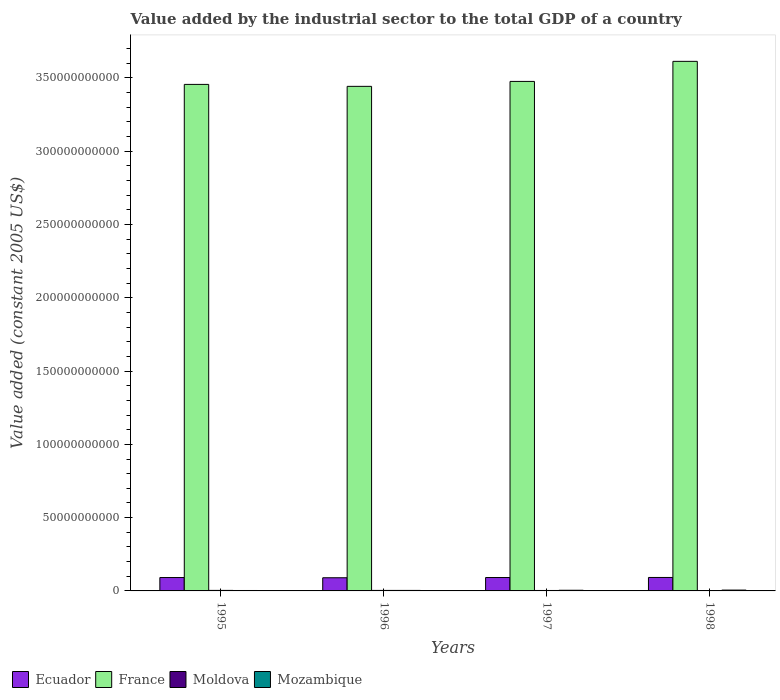How many groups of bars are there?
Make the answer very short. 4. Are the number of bars per tick equal to the number of legend labels?
Your answer should be compact. Yes. Are the number of bars on each tick of the X-axis equal?
Your answer should be compact. Yes. How many bars are there on the 3rd tick from the left?
Your response must be concise. 4. How many bars are there on the 3rd tick from the right?
Provide a short and direct response. 4. In how many cases, is the number of bars for a given year not equal to the number of legend labels?
Your response must be concise. 0. What is the value added by the industrial sector in France in 1998?
Keep it short and to the point. 3.61e+11. Across all years, what is the maximum value added by the industrial sector in France?
Your answer should be very brief. 3.61e+11. Across all years, what is the minimum value added by the industrial sector in Ecuador?
Your response must be concise. 8.99e+09. What is the total value added by the industrial sector in Moldova in the graph?
Give a very brief answer. 1.26e+09. What is the difference between the value added by the industrial sector in Mozambique in 1995 and that in 1996?
Provide a succinct answer. -5.12e+07. What is the difference between the value added by the industrial sector in Ecuador in 1998 and the value added by the industrial sector in France in 1996?
Your answer should be compact. -3.35e+11. What is the average value added by the industrial sector in Mozambique per year?
Offer a very short reply. 4.16e+08. In the year 1996, what is the difference between the value added by the industrial sector in Moldova and value added by the industrial sector in Ecuador?
Provide a short and direct response. -8.64e+09. What is the ratio of the value added by the industrial sector in Mozambique in 1996 to that in 1998?
Offer a terse response. 0.61. Is the value added by the industrial sector in Moldova in 1996 less than that in 1997?
Keep it short and to the point. No. Is the difference between the value added by the industrial sector in Moldova in 1996 and 1998 greater than the difference between the value added by the industrial sector in Ecuador in 1996 and 1998?
Your answer should be compact. Yes. What is the difference between the highest and the second highest value added by the industrial sector in Ecuador?
Your response must be concise. 4.20e+07. What is the difference between the highest and the lowest value added by the industrial sector in France?
Ensure brevity in your answer.  1.71e+1. In how many years, is the value added by the industrial sector in Mozambique greater than the average value added by the industrial sector in Mozambique taken over all years?
Your response must be concise. 2. Is it the case that in every year, the sum of the value added by the industrial sector in Moldova and value added by the industrial sector in France is greater than the sum of value added by the industrial sector in Mozambique and value added by the industrial sector in Ecuador?
Your answer should be compact. Yes. What does the 2nd bar from the left in 1995 represents?
Provide a short and direct response. France. What does the 4th bar from the right in 1995 represents?
Give a very brief answer. Ecuador. Is it the case that in every year, the sum of the value added by the industrial sector in Mozambique and value added by the industrial sector in Moldova is greater than the value added by the industrial sector in Ecuador?
Make the answer very short. No. How many bars are there?
Provide a short and direct response. 16. Are all the bars in the graph horizontal?
Ensure brevity in your answer.  No. What is the difference between two consecutive major ticks on the Y-axis?
Keep it short and to the point. 5.00e+1. Are the values on the major ticks of Y-axis written in scientific E-notation?
Make the answer very short. No. Does the graph contain grids?
Offer a very short reply. No. Where does the legend appear in the graph?
Give a very brief answer. Bottom left. How many legend labels are there?
Provide a succinct answer. 4. What is the title of the graph?
Provide a succinct answer. Value added by the industrial sector to the total GDP of a country. Does "Finland" appear as one of the legend labels in the graph?
Offer a terse response. No. What is the label or title of the Y-axis?
Your answer should be very brief. Value added (constant 2005 US$). What is the Value added (constant 2005 US$) in Ecuador in 1995?
Your response must be concise. 9.13e+09. What is the Value added (constant 2005 US$) in France in 1995?
Provide a succinct answer. 3.46e+11. What is the Value added (constant 2005 US$) of Moldova in 1995?
Your answer should be very brief. 3.52e+08. What is the Value added (constant 2005 US$) of Mozambique in 1995?
Keep it short and to the point. 2.97e+08. What is the Value added (constant 2005 US$) in Ecuador in 1996?
Provide a succinct answer. 8.99e+09. What is the Value added (constant 2005 US$) of France in 1996?
Your answer should be very brief. 3.44e+11. What is the Value added (constant 2005 US$) in Moldova in 1996?
Offer a terse response. 3.45e+08. What is the Value added (constant 2005 US$) in Mozambique in 1996?
Ensure brevity in your answer.  3.48e+08. What is the Value added (constant 2005 US$) in Ecuador in 1997?
Offer a terse response. 9.14e+09. What is the Value added (constant 2005 US$) of France in 1997?
Provide a succinct answer. 3.48e+11. What is the Value added (constant 2005 US$) in Moldova in 1997?
Offer a very short reply. 3.05e+08. What is the Value added (constant 2005 US$) in Mozambique in 1997?
Make the answer very short. 4.52e+08. What is the Value added (constant 2005 US$) of Ecuador in 1998?
Give a very brief answer. 9.19e+09. What is the Value added (constant 2005 US$) of France in 1998?
Provide a short and direct response. 3.61e+11. What is the Value added (constant 2005 US$) in Moldova in 1998?
Offer a terse response. 2.59e+08. What is the Value added (constant 2005 US$) in Mozambique in 1998?
Your answer should be compact. 5.69e+08. Across all years, what is the maximum Value added (constant 2005 US$) in Ecuador?
Your answer should be compact. 9.19e+09. Across all years, what is the maximum Value added (constant 2005 US$) of France?
Give a very brief answer. 3.61e+11. Across all years, what is the maximum Value added (constant 2005 US$) in Moldova?
Offer a very short reply. 3.52e+08. Across all years, what is the maximum Value added (constant 2005 US$) in Mozambique?
Provide a succinct answer. 5.69e+08. Across all years, what is the minimum Value added (constant 2005 US$) in Ecuador?
Your answer should be compact. 8.99e+09. Across all years, what is the minimum Value added (constant 2005 US$) of France?
Give a very brief answer. 3.44e+11. Across all years, what is the minimum Value added (constant 2005 US$) of Moldova?
Give a very brief answer. 2.59e+08. Across all years, what is the minimum Value added (constant 2005 US$) in Mozambique?
Your answer should be compact. 2.97e+08. What is the total Value added (constant 2005 US$) of Ecuador in the graph?
Offer a very short reply. 3.65e+1. What is the total Value added (constant 2005 US$) of France in the graph?
Ensure brevity in your answer.  1.40e+12. What is the total Value added (constant 2005 US$) in Moldova in the graph?
Your answer should be very brief. 1.26e+09. What is the total Value added (constant 2005 US$) in Mozambique in the graph?
Ensure brevity in your answer.  1.67e+09. What is the difference between the Value added (constant 2005 US$) of Ecuador in 1995 and that in 1996?
Ensure brevity in your answer.  1.48e+08. What is the difference between the Value added (constant 2005 US$) of France in 1995 and that in 1996?
Your answer should be compact. 1.33e+09. What is the difference between the Value added (constant 2005 US$) in Moldova in 1995 and that in 1996?
Ensure brevity in your answer.  7.55e+06. What is the difference between the Value added (constant 2005 US$) in Mozambique in 1995 and that in 1996?
Offer a very short reply. -5.12e+07. What is the difference between the Value added (constant 2005 US$) in Ecuador in 1995 and that in 1997?
Provide a short and direct response. -9.61e+06. What is the difference between the Value added (constant 2005 US$) in France in 1995 and that in 1997?
Offer a terse response. -2.03e+09. What is the difference between the Value added (constant 2005 US$) in Moldova in 1995 and that in 1997?
Keep it short and to the point. 4.72e+07. What is the difference between the Value added (constant 2005 US$) in Mozambique in 1995 and that in 1997?
Provide a short and direct response. -1.55e+08. What is the difference between the Value added (constant 2005 US$) in Ecuador in 1995 and that in 1998?
Ensure brevity in your answer.  -5.16e+07. What is the difference between the Value added (constant 2005 US$) of France in 1995 and that in 1998?
Make the answer very short. -1.57e+1. What is the difference between the Value added (constant 2005 US$) of Moldova in 1995 and that in 1998?
Give a very brief answer. 9.35e+07. What is the difference between the Value added (constant 2005 US$) of Mozambique in 1995 and that in 1998?
Your response must be concise. -2.72e+08. What is the difference between the Value added (constant 2005 US$) in Ecuador in 1996 and that in 1997?
Make the answer very short. -1.57e+08. What is the difference between the Value added (constant 2005 US$) in France in 1996 and that in 1997?
Give a very brief answer. -3.36e+09. What is the difference between the Value added (constant 2005 US$) in Moldova in 1996 and that in 1997?
Provide a succinct answer. 3.97e+07. What is the difference between the Value added (constant 2005 US$) of Mozambique in 1996 and that in 1997?
Offer a very short reply. -1.04e+08. What is the difference between the Value added (constant 2005 US$) of Ecuador in 1996 and that in 1998?
Provide a short and direct response. -1.99e+08. What is the difference between the Value added (constant 2005 US$) in France in 1996 and that in 1998?
Ensure brevity in your answer.  -1.71e+1. What is the difference between the Value added (constant 2005 US$) of Moldova in 1996 and that in 1998?
Provide a succinct answer. 8.60e+07. What is the difference between the Value added (constant 2005 US$) of Mozambique in 1996 and that in 1998?
Ensure brevity in your answer.  -2.21e+08. What is the difference between the Value added (constant 2005 US$) in Ecuador in 1997 and that in 1998?
Provide a succinct answer. -4.20e+07. What is the difference between the Value added (constant 2005 US$) in France in 1997 and that in 1998?
Provide a succinct answer. -1.37e+1. What is the difference between the Value added (constant 2005 US$) of Moldova in 1997 and that in 1998?
Your answer should be very brief. 4.63e+07. What is the difference between the Value added (constant 2005 US$) in Mozambique in 1997 and that in 1998?
Ensure brevity in your answer.  -1.17e+08. What is the difference between the Value added (constant 2005 US$) of Ecuador in 1995 and the Value added (constant 2005 US$) of France in 1996?
Your answer should be compact. -3.35e+11. What is the difference between the Value added (constant 2005 US$) in Ecuador in 1995 and the Value added (constant 2005 US$) in Moldova in 1996?
Offer a terse response. 8.79e+09. What is the difference between the Value added (constant 2005 US$) in Ecuador in 1995 and the Value added (constant 2005 US$) in Mozambique in 1996?
Offer a terse response. 8.79e+09. What is the difference between the Value added (constant 2005 US$) of France in 1995 and the Value added (constant 2005 US$) of Moldova in 1996?
Keep it short and to the point. 3.45e+11. What is the difference between the Value added (constant 2005 US$) in France in 1995 and the Value added (constant 2005 US$) in Mozambique in 1996?
Keep it short and to the point. 3.45e+11. What is the difference between the Value added (constant 2005 US$) of Moldova in 1995 and the Value added (constant 2005 US$) of Mozambique in 1996?
Your answer should be compact. 4.58e+06. What is the difference between the Value added (constant 2005 US$) of Ecuador in 1995 and the Value added (constant 2005 US$) of France in 1997?
Your answer should be very brief. -3.39e+11. What is the difference between the Value added (constant 2005 US$) of Ecuador in 1995 and the Value added (constant 2005 US$) of Moldova in 1997?
Give a very brief answer. 8.83e+09. What is the difference between the Value added (constant 2005 US$) in Ecuador in 1995 and the Value added (constant 2005 US$) in Mozambique in 1997?
Your answer should be very brief. 8.68e+09. What is the difference between the Value added (constant 2005 US$) of France in 1995 and the Value added (constant 2005 US$) of Moldova in 1997?
Provide a succinct answer. 3.45e+11. What is the difference between the Value added (constant 2005 US$) in France in 1995 and the Value added (constant 2005 US$) in Mozambique in 1997?
Your response must be concise. 3.45e+11. What is the difference between the Value added (constant 2005 US$) in Moldova in 1995 and the Value added (constant 2005 US$) in Mozambique in 1997?
Provide a short and direct response. -9.92e+07. What is the difference between the Value added (constant 2005 US$) of Ecuador in 1995 and the Value added (constant 2005 US$) of France in 1998?
Make the answer very short. -3.52e+11. What is the difference between the Value added (constant 2005 US$) of Ecuador in 1995 and the Value added (constant 2005 US$) of Moldova in 1998?
Make the answer very short. 8.88e+09. What is the difference between the Value added (constant 2005 US$) of Ecuador in 1995 and the Value added (constant 2005 US$) of Mozambique in 1998?
Provide a short and direct response. 8.57e+09. What is the difference between the Value added (constant 2005 US$) in France in 1995 and the Value added (constant 2005 US$) in Moldova in 1998?
Offer a very short reply. 3.45e+11. What is the difference between the Value added (constant 2005 US$) in France in 1995 and the Value added (constant 2005 US$) in Mozambique in 1998?
Your answer should be very brief. 3.45e+11. What is the difference between the Value added (constant 2005 US$) of Moldova in 1995 and the Value added (constant 2005 US$) of Mozambique in 1998?
Ensure brevity in your answer.  -2.17e+08. What is the difference between the Value added (constant 2005 US$) of Ecuador in 1996 and the Value added (constant 2005 US$) of France in 1997?
Provide a short and direct response. -3.39e+11. What is the difference between the Value added (constant 2005 US$) of Ecuador in 1996 and the Value added (constant 2005 US$) of Moldova in 1997?
Your answer should be compact. 8.68e+09. What is the difference between the Value added (constant 2005 US$) of Ecuador in 1996 and the Value added (constant 2005 US$) of Mozambique in 1997?
Ensure brevity in your answer.  8.53e+09. What is the difference between the Value added (constant 2005 US$) of France in 1996 and the Value added (constant 2005 US$) of Moldova in 1997?
Your response must be concise. 3.44e+11. What is the difference between the Value added (constant 2005 US$) in France in 1996 and the Value added (constant 2005 US$) in Mozambique in 1997?
Provide a short and direct response. 3.44e+11. What is the difference between the Value added (constant 2005 US$) in Moldova in 1996 and the Value added (constant 2005 US$) in Mozambique in 1997?
Make the answer very short. -1.07e+08. What is the difference between the Value added (constant 2005 US$) in Ecuador in 1996 and the Value added (constant 2005 US$) in France in 1998?
Make the answer very short. -3.52e+11. What is the difference between the Value added (constant 2005 US$) in Ecuador in 1996 and the Value added (constant 2005 US$) in Moldova in 1998?
Provide a succinct answer. 8.73e+09. What is the difference between the Value added (constant 2005 US$) in Ecuador in 1996 and the Value added (constant 2005 US$) in Mozambique in 1998?
Your answer should be very brief. 8.42e+09. What is the difference between the Value added (constant 2005 US$) of France in 1996 and the Value added (constant 2005 US$) of Moldova in 1998?
Your response must be concise. 3.44e+11. What is the difference between the Value added (constant 2005 US$) of France in 1996 and the Value added (constant 2005 US$) of Mozambique in 1998?
Your answer should be compact. 3.44e+11. What is the difference between the Value added (constant 2005 US$) in Moldova in 1996 and the Value added (constant 2005 US$) in Mozambique in 1998?
Your answer should be very brief. -2.24e+08. What is the difference between the Value added (constant 2005 US$) of Ecuador in 1997 and the Value added (constant 2005 US$) of France in 1998?
Your response must be concise. -3.52e+11. What is the difference between the Value added (constant 2005 US$) of Ecuador in 1997 and the Value added (constant 2005 US$) of Moldova in 1998?
Give a very brief answer. 8.89e+09. What is the difference between the Value added (constant 2005 US$) in Ecuador in 1997 and the Value added (constant 2005 US$) in Mozambique in 1998?
Offer a very short reply. 8.57e+09. What is the difference between the Value added (constant 2005 US$) in France in 1997 and the Value added (constant 2005 US$) in Moldova in 1998?
Ensure brevity in your answer.  3.47e+11. What is the difference between the Value added (constant 2005 US$) of France in 1997 and the Value added (constant 2005 US$) of Mozambique in 1998?
Your answer should be very brief. 3.47e+11. What is the difference between the Value added (constant 2005 US$) of Moldova in 1997 and the Value added (constant 2005 US$) of Mozambique in 1998?
Offer a terse response. -2.64e+08. What is the average Value added (constant 2005 US$) in Ecuador per year?
Your answer should be compact. 9.11e+09. What is the average Value added (constant 2005 US$) in France per year?
Offer a very short reply. 3.50e+11. What is the average Value added (constant 2005 US$) of Moldova per year?
Keep it short and to the point. 3.15e+08. What is the average Value added (constant 2005 US$) of Mozambique per year?
Provide a succinct answer. 4.16e+08. In the year 1995, what is the difference between the Value added (constant 2005 US$) of Ecuador and Value added (constant 2005 US$) of France?
Give a very brief answer. -3.36e+11. In the year 1995, what is the difference between the Value added (constant 2005 US$) in Ecuador and Value added (constant 2005 US$) in Moldova?
Offer a terse response. 8.78e+09. In the year 1995, what is the difference between the Value added (constant 2005 US$) in Ecuador and Value added (constant 2005 US$) in Mozambique?
Provide a succinct answer. 8.84e+09. In the year 1995, what is the difference between the Value added (constant 2005 US$) in France and Value added (constant 2005 US$) in Moldova?
Your response must be concise. 3.45e+11. In the year 1995, what is the difference between the Value added (constant 2005 US$) in France and Value added (constant 2005 US$) in Mozambique?
Offer a very short reply. 3.45e+11. In the year 1995, what is the difference between the Value added (constant 2005 US$) in Moldova and Value added (constant 2005 US$) in Mozambique?
Make the answer very short. 5.58e+07. In the year 1996, what is the difference between the Value added (constant 2005 US$) of Ecuador and Value added (constant 2005 US$) of France?
Make the answer very short. -3.35e+11. In the year 1996, what is the difference between the Value added (constant 2005 US$) in Ecuador and Value added (constant 2005 US$) in Moldova?
Your response must be concise. 8.64e+09. In the year 1996, what is the difference between the Value added (constant 2005 US$) in Ecuador and Value added (constant 2005 US$) in Mozambique?
Your response must be concise. 8.64e+09. In the year 1996, what is the difference between the Value added (constant 2005 US$) of France and Value added (constant 2005 US$) of Moldova?
Offer a terse response. 3.44e+11. In the year 1996, what is the difference between the Value added (constant 2005 US$) in France and Value added (constant 2005 US$) in Mozambique?
Your answer should be compact. 3.44e+11. In the year 1996, what is the difference between the Value added (constant 2005 US$) of Moldova and Value added (constant 2005 US$) of Mozambique?
Keep it short and to the point. -2.97e+06. In the year 1997, what is the difference between the Value added (constant 2005 US$) of Ecuador and Value added (constant 2005 US$) of France?
Provide a short and direct response. -3.39e+11. In the year 1997, what is the difference between the Value added (constant 2005 US$) of Ecuador and Value added (constant 2005 US$) of Moldova?
Give a very brief answer. 8.84e+09. In the year 1997, what is the difference between the Value added (constant 2005 US$) in Ecuador and Value added (constant 2005 US$) in Mozambique?
Give a very brief answer. 8.69e+09. In the year 1997, what is the difference between the Value added (constant 2005 US$) in France and Value added (constant 2005 US$) in Moldova?
Give a very brief answer. 3.47e+11. In the year 1997, what is the difference between the Value added (constant 2005 US$) in France and Value added (constant 2005 US$) in Mozambique?
Keep it short and to the point. 3.47e+11. In the year 1997, what is the difference between the Value added (constant 2005 US$) in Moldova and Value added (constant 2005 US$) in Mozambique?
Provide a short and direct response. -1.46e+08. In the year 1998, what is the difference between the Value added (constant 2005 US$) of Ecuador and Value added (constant 2005 US$) of France?
Provide a succinct answer. -3.52e+11. In the year 1998, what is the difference between the Value added (constant 2005 US$) of Ecuador and Value added (constant 2005 US$) of Moldova?
Give a very brief answer. 8.93e+09. In the year 1998, what is the difference between the Value added (constant 2005 US$) in Ecuador and Value added (constant 2005 US$) in Mozambique?
Give a very brief answer. 8.62e+09. In the year 1998, what is the difference between the Value added (constant 2005 US$) in France and Value added (constant 2005 US$) in Moldova?
Your answer should be very brief. 3.61e+11. In the year 1998, what is the difference between the Value added (constant 2005 US$) of France and Value added (constant 2005 US$) of Mozambique?
Your answer should be compact. 3.61e+11. In the year 1998, what is the difference between the Value added (constant 2005 US$) of Moldova and Value added (constant 2005 US$) of Mozambique?
Make the answer very short. -3.10e+08. What is the ratio of the Value added (constant 2005 US$) of Ecuador in 1995 to that in 1996?
Ensure brevity in your answer.  1.02. What is the ratio of the Value added (constant 2005 US$) of Moldova in 1995 to that in 1996?
Your answer should be very brief. 1.02. What is the ratio of the Value added (constant 2005 US$) of Mozambique in 1995 to that in 1996?
Provide a succinct answer. 0.85. What is the ratio of the Value added (constant 2005 US$) in Ecuador in 1995 to that in 1997?
Your answer should be very brief. 1. What is the ratio of the Value added (constant 2005 US$) in France in 1995 to that in 1997?
Ensure brevity in your answer.  0.99. What is the ratio of the Value added (constant 2005 US$) in Moldova in 1995 to that in 1997?
Offer a terse response. 1.15. What is the ratio of the Value added (constant 2005 US$) in Mozambique in 1995 to that in 1997?
Your answer should be very brief. 0.66. What is the ratio of the Value added (constant 2005 US$) in France in 1995 to that in 1998?
Your answer should be compact. 0.96. What is the ratio of the Value added (constant 2005 US$) in Moldova in 1995 to that in 1998?
Provide a short and direct response. 1.36. What is the ratio of the Value added (constant 2005 US$) of Mozambique in 1995 to that in 1998?
Your response must be concise. 0.52. What is the ratio of the Value added (constant 2005 US$) of Ecuador in 1996 to that in 1997?
Provide a succinct answer. 0.98. What is the ratio of the Value added (constant 2005 US$) of France in 1996 to that in 1997?
Offer a terse response. 0.99. What is the ratio of the Value added (constant 2005 US$) in Moldova in 1996 to that in 1997?
Offer a very short reply. 1.13. What is the ratio of the Value added (constant 2005 US$) in Mozambique in 1996 to that in 1997?
Your answer should be compact. 0.77. What is the ratio of the Value added (constant 2005 US$) of Ecuador in 1996 to that in 1998?
Offer a terse response. 0.98. What is the ratio of the Value added (constant 2005 US$) of France in 1996 to that in 1998?
Your response must be concise. 0.95. What is the ratio of the Value added (constant 2005 US$) of Moldova in 1996 to that in 1998?
Your answer should be compact. 1.33. What is the ratio of the Value added (constant 2005 US$) of Mozambique in 1996 to that in 1998?
Keep it short and to the point. 0.61. What is the ratio of the Value added (constant 2005 US$) in Ecuador in 1997 to that in 1998?
Give a very brief answer. 1. What is the ratio of the Value added (constant 2005 US$) of France in 1997 to that in 1998?
Ensure brevity in your answer.  0.96. What is the ratio of the Value added (constant 2005 US$) in Moldova in 1997 to that in 1998?
Your answer should be very brief. 1.18. What is the ratio of the Value added (constant 2005 US$) of Mozambique in 1997 to that in 1998?
Your answer should be very brief. 0.79. What is the difference between the highest and the second highest Value added (constant 2005 US$) of Ecuador?
Your response must be concise. 4.20e+07. What is the difference between the highest and the second highest Value added (constant 2005 US$) of France?
Offer a very short reply. 1.37e+1. What is the difference between the highest and the second highest Value added (constant 2005 US$) in Moldova?
Ensure brevity in your answer.  7.55e+06. What is the difference between the highest and the second highest Value added (constant 2005 US$) of Mozambique?
Offer a very short reply. 1.17e+08. What is the difference between the highest and the lowest Value added (constant 2005 US$) in Ecuador?
Offer a terse response. 1.99e+08. What is the difference between the highest and the lowest Value added (constant 2005 US$) of France?
Your answer should be very brief. 1.71e+1. What is the difference between the highest and the lowest Value added (constant 2005 US$) of Moldova?
Provide a succinct answer. 9.35e+07. What is the difference between the highest and the lowest Value added (constant 2005 US$) of Mozambique?
Offer a terse response. 2.72e+08. 